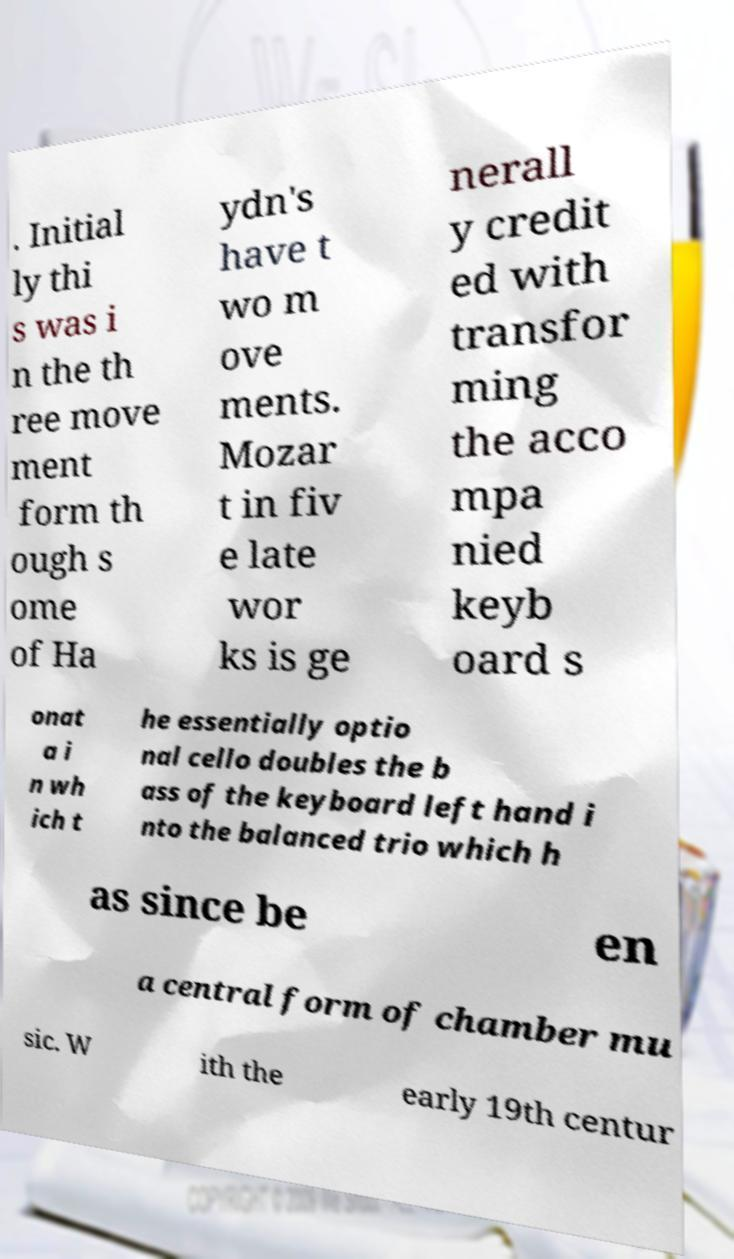Can you accurately transcribe the text from the provided image for me? . Initial ly thi s was i n the th ree move ment form th ough s ome of Ha ydn's have t wo m ove ments. Mozar t in fiv e late wor ks is ge nerall y credit ed with transfor ming the acco mpa nied keyb oard s onat a i n wh ich t he essentially optio nal cello doubles the b ass of the keyboard left hand i nto the balanced trio which h as since be en a central form of chamber mu sic. W ith the early 19th centur 